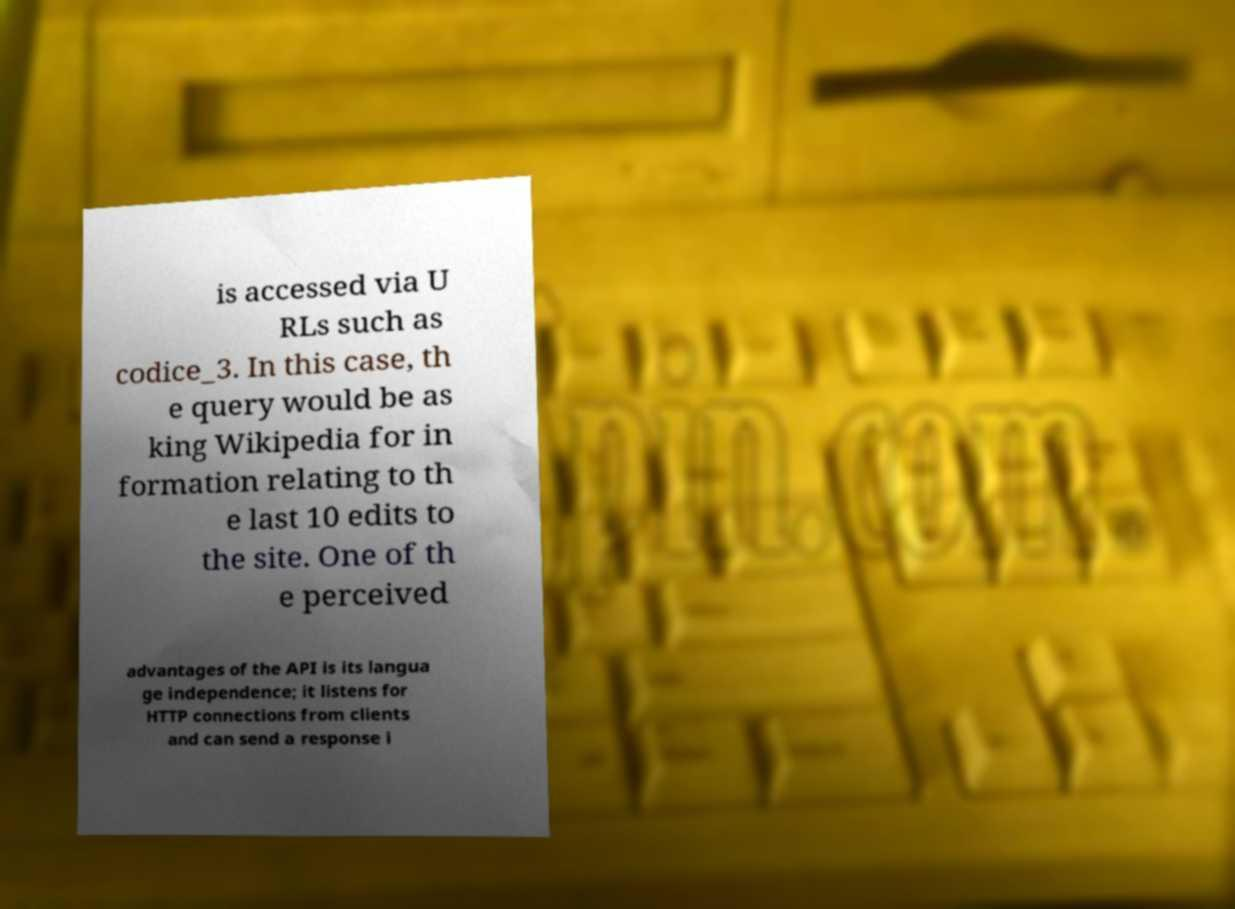There's text embedded in this image that I need extracted. Can you transcribe it verbatim? is accessed via U RLs such as codice_3. In this case, th e query would be as king Wikipedia for in formation relating to th e last 10 edits to the site. One of th e perceived advantages of the API is its langua ge independence; it listens for HTTP connections from clients and can send a response i 